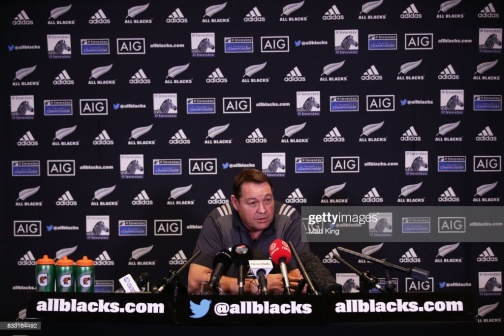Why might there be so many water bottles on the desk? The numerous water bottles suggest that the man might be speaking for an extended period, such as in a lengthy press conference or interview where staying hydrated is essential. It is also common for sponsors to place products prominently during such events for brand visibility. 